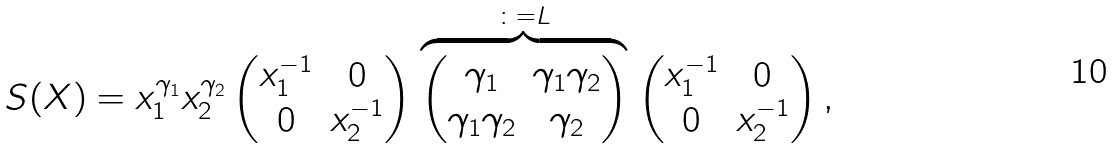Convert formula to latex. <formula><loc_0><loc_0><loc_500><loc_500>S ( X ) & = x _ { 1 } ^ { \gamma _ { 1 } } x _ { 2 } ^ { \gamma _ { 2 } } \begin{pmatrix} x _ { 1 } ^ { - 1 } & 0 \\ 0 & x _ { 2 } ^ { - 1 } \end{pmatrix} \stackrel { \colon = L } { \overbrace { \begin{pmatrix} \gamma _ { 1 } & \gamma _ { 1 } \gamma _ { 2 } \\ \gamma _ { 1 } \gamma _ { 2 } & \gamma _ { 2 } \\ \end{pmatrix} } } \begin{pmatrix} x _ { 1 } ^ { - 1 } & 0 \\ 0 & x _ { 2 } ^ { - 1 } \end{pmatrix} ,</formula> 